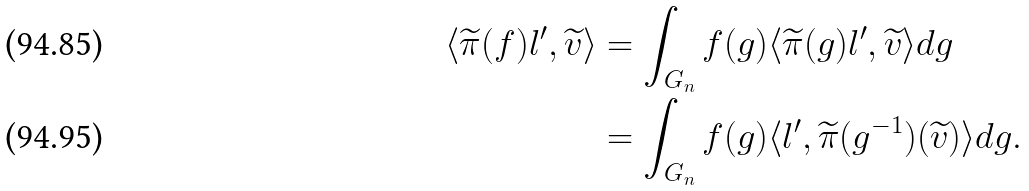Convert formula to latex. <formula><loc_0><loc_0><loc_500><loc_500>\langle \widetilde { \pi } ( f ) l ^ { \prime } , \widetilde { v } \rangle & = \int _ { G _ { n } } f ( g ) \langle \widetilde { \pi } ( g ) l ^ { \prime } , \widetilde { v } \rangle d g \\ & = \int _ { G _ { n } } f ( g ) \langle l ^ { \prime } , \widetilde { \pi } ( g ^ { - 1 } ) ( \widetilde { v } ) \rangle d g .</formula> 